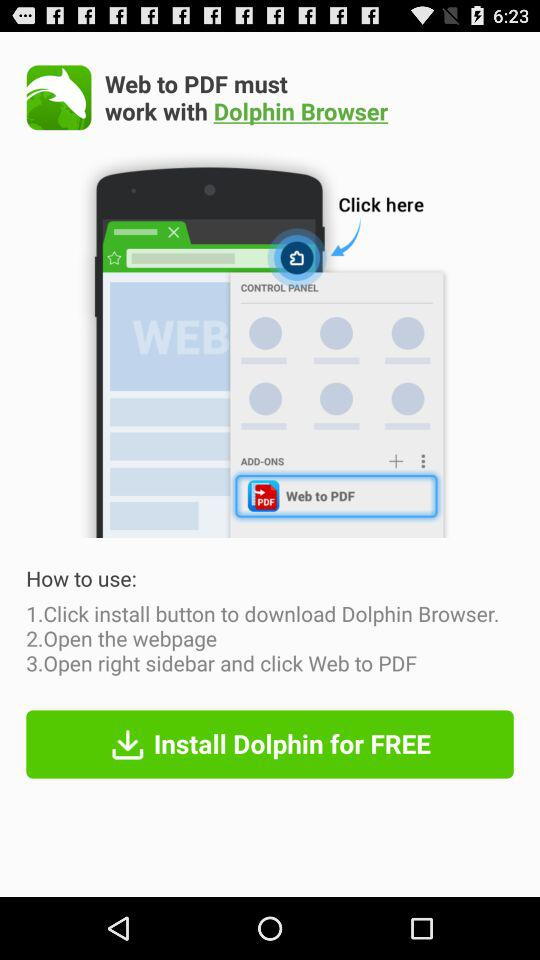What's the price of "Dolphin Browser"? "Dolphin Browser" is free. 